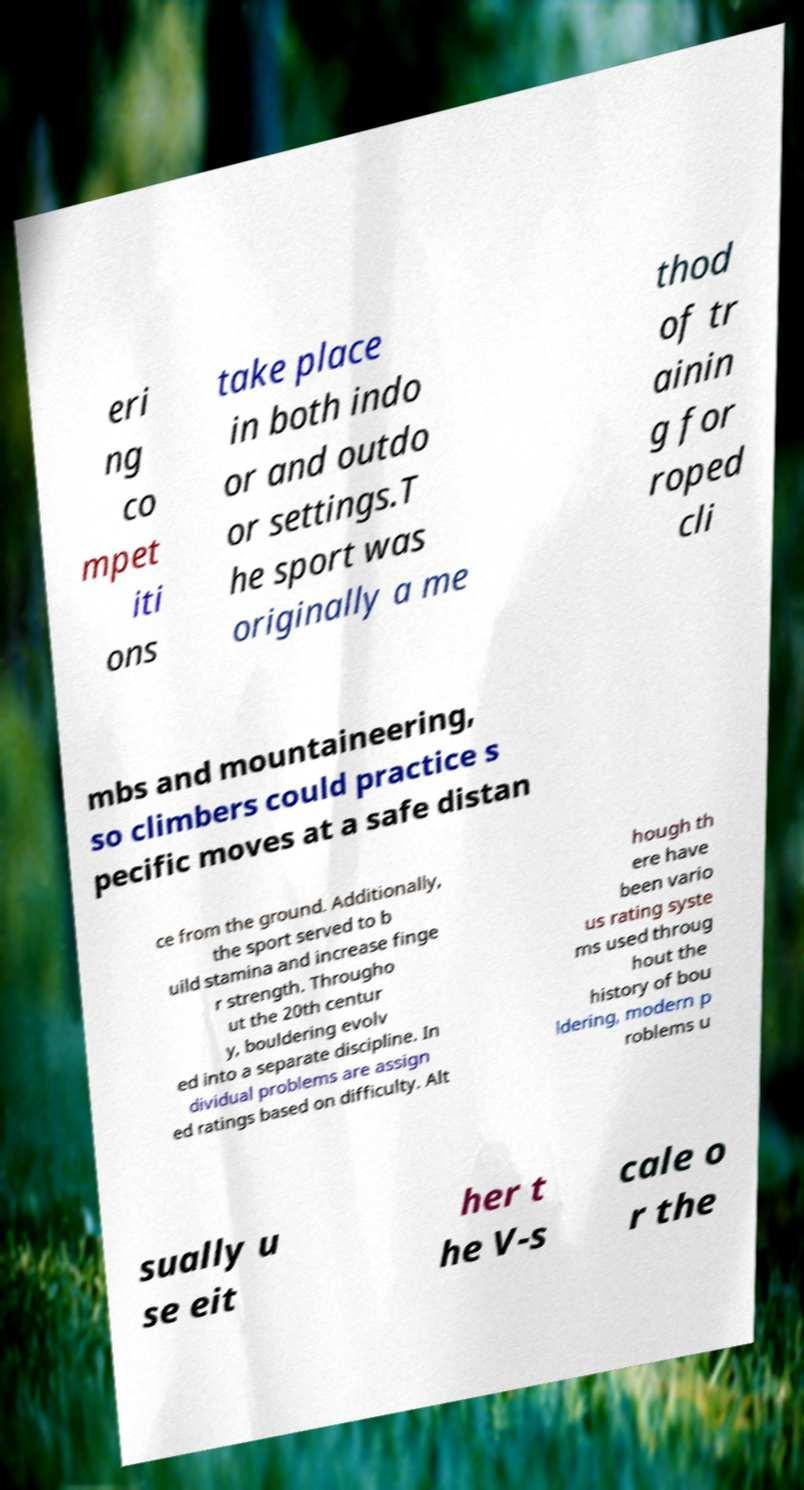What messages or text are displayed in this image? I need them in a readable, typed format. eri ng co mpet iti ons take place in both indo or and outdo or settings.T he sport was originally a me thod of tr ainin g for roped cli mbs and mountaineering, so climbers could practice s pecific moves at a safe distan ce from the ground. Additionally, the sport served to b uild stamina and increase finge r strength. Througho ut the 20th centur y, bouldering evolv ed into a separate discipline. In dividual problems are assign ed ratings based on difficulty. Alt hough th ere have been vario us rating syste ms used throug hout the history of bou ldering, modern p roblems u sually u se eit her t he V-s cale o r the 